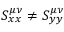<formula> <loc_0><loc_0><loc_500><loc_500>S _ { x x } ^ { \mu \nu } \neq S _ { y y } ^ { \mu \nu }</formula> 